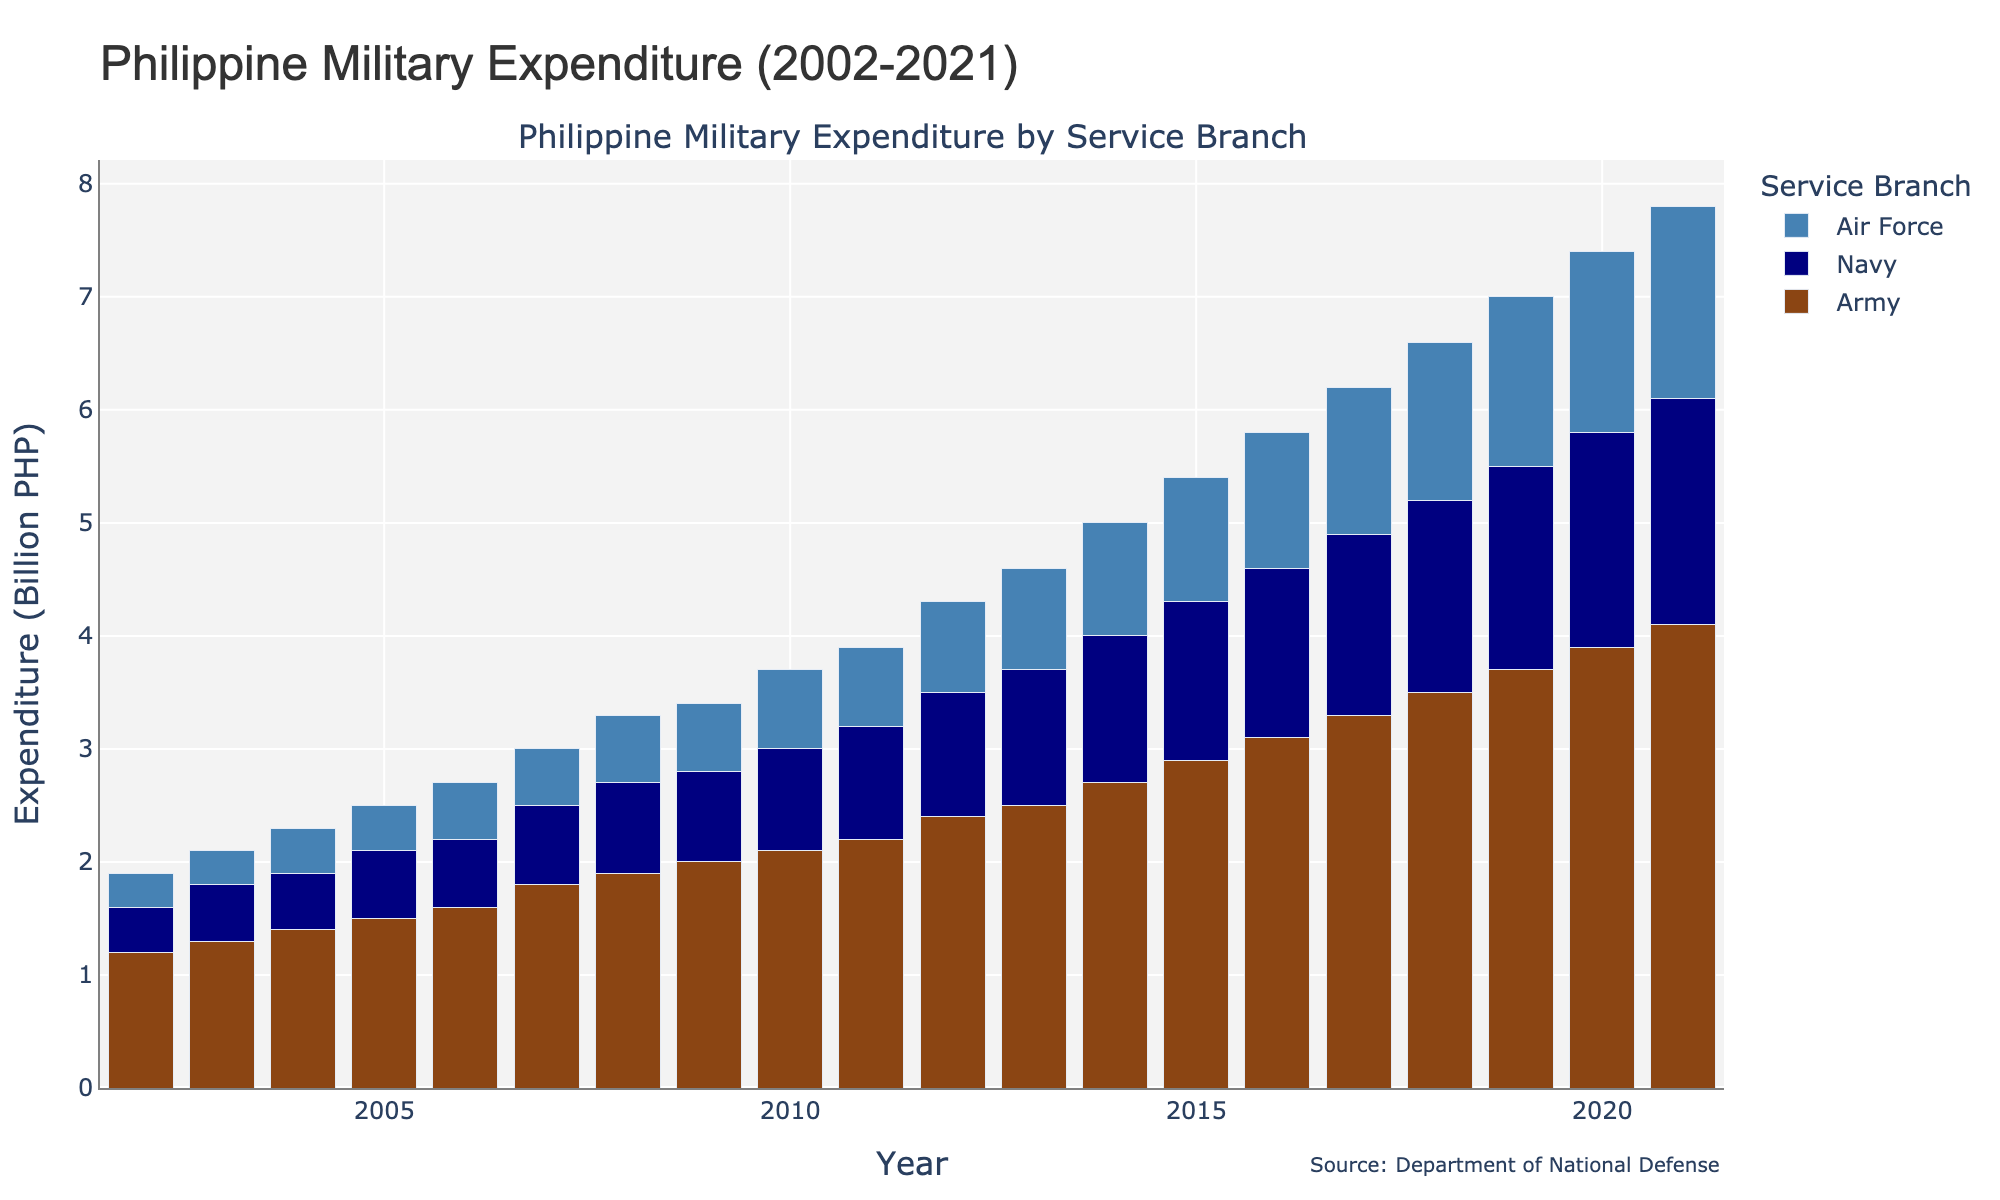What's the total military expenditure in 2010? According to the figure, the overall height of the stacked bar for the year 2010, which includes Army, Navy, and Air Force expenditure, sums up to the "Total" value on the y-axis marked for 2010.
Answer: 3.7 billion PHP Which branch had the highest expenditure in 2015? By examining the height of the bars for each service branch in 2015, we can see that the "Army" bar is the tallest, indicating the highest expenditure among the three branches.
Answer: Army By how much did the total military expenditure increase from 2005 to 2021? To find the increase, we subtract the total expenditure in 2005 (2.5 billion PHP) from the total expenditure in 2021 (7.8 billion PHP). This is 7.8 - 2.5 = 5.3 billion PHP.
Answer: 5.3 billion PHP What was the average expenditure of the Navy over the past 20 years? We find the average by summing up the expenditures for the Navy from each year (0.4 + 0.5 + 0.5 + 0.6 + 0.6 + 0.7 + 0.8 + 0.8 + 0.9 + 1.0 + 1.1 + 1.2 + 1.3 + 1.4 + 1.5 + 1.6 + 1.7 + 1.8 + 1.9 + 2.0 = 24.8 billion PHP) and then dividing by 20.
Answer: 1.24 billion PHP Which year saw the highest increase in total military expenditure compared to the previous year? We need to calculate the increase for each year: 
  - 2003: 2.1 - 1.9 = 0.2
  - 2004: 2.3 - 2.1 = 0.2
  - 2005: 2.5 - 2.3 = 0.2
  ...
  - 2015: 5.4 - 5.0 = 0.4
  - 2016: 5.8 - 5.4 = 0.4
  - 2017: 6.2 - 5.8 = 0.4
  - 2018: 6.6 - 6.2 = 0.4
  - 2019: 7.0 - 6.6 = 0.4
  - 2020: 7.4 - 7.0 = 0.4
  - 2021: 7.8 - 7.4 = 0.4
  The highest increment is 0.4 billion PHP, found in multiple years (2015, 2016, 2017, 2018, 2019, 2020, 2021).
Answer: 2015, 2016, 2017, 2018, 2019, 2020, 2021 In which years did the Air Force's expenditure surpass 1.0 billion PHP? Observing the heights of the bars specifically for the Air Force, we see that this expenditure level is reached from 2014 onwards.
Answer: 2014, 2015, 2016, 2017, 2018, 2019, 2020, 2021 